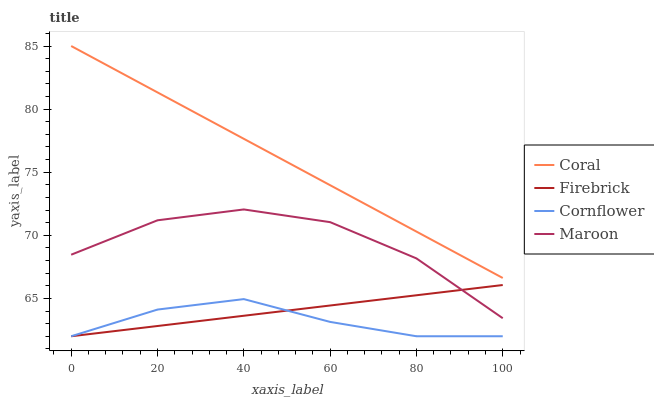Does Cornflower have the minimum area under the curve?
Answer yes or no. Yes. Does Coral have the maximum area under the curve?
Answer yes or no. Yes. Does Firebrick have the minimum area under the curve?
Answer yes or no. No. Does Firebrick have the maximum area under the curve?
Answer yes or no. No. Is Coral the smoothest?
Answer yes or no. Yes. Is Maroon the roughest?
Answer yes or no. Yes. Is Firebrick the smoothest?
Answer yes or no. No. Is Firebrick the roughest?
Answer yes or no. No. Does Cornflower have the lowest value?
Answer yes or no. Yes. Does Coral have the lowest value?
Answer yes or no. No. Does Coral have the highest value?
Answer yes or no. Yes. Does Firebrick have the highest value?
Answer yes or no. No. Is Cornflower less than Maroon?
Answer yes or no. Yes. Is Maroon greater than Cornflower?
Answer yes or no. Yes. Does Firebrick intersect Maroon?
Answer yes or no. Yes. Is Firebrick less than Maroon?
Answer yes or no. No. Is Firebrick greater than Maroon?
Answer yes or no. No. Does Cornflower intersect Maroon?
Answer yes or no. No. 